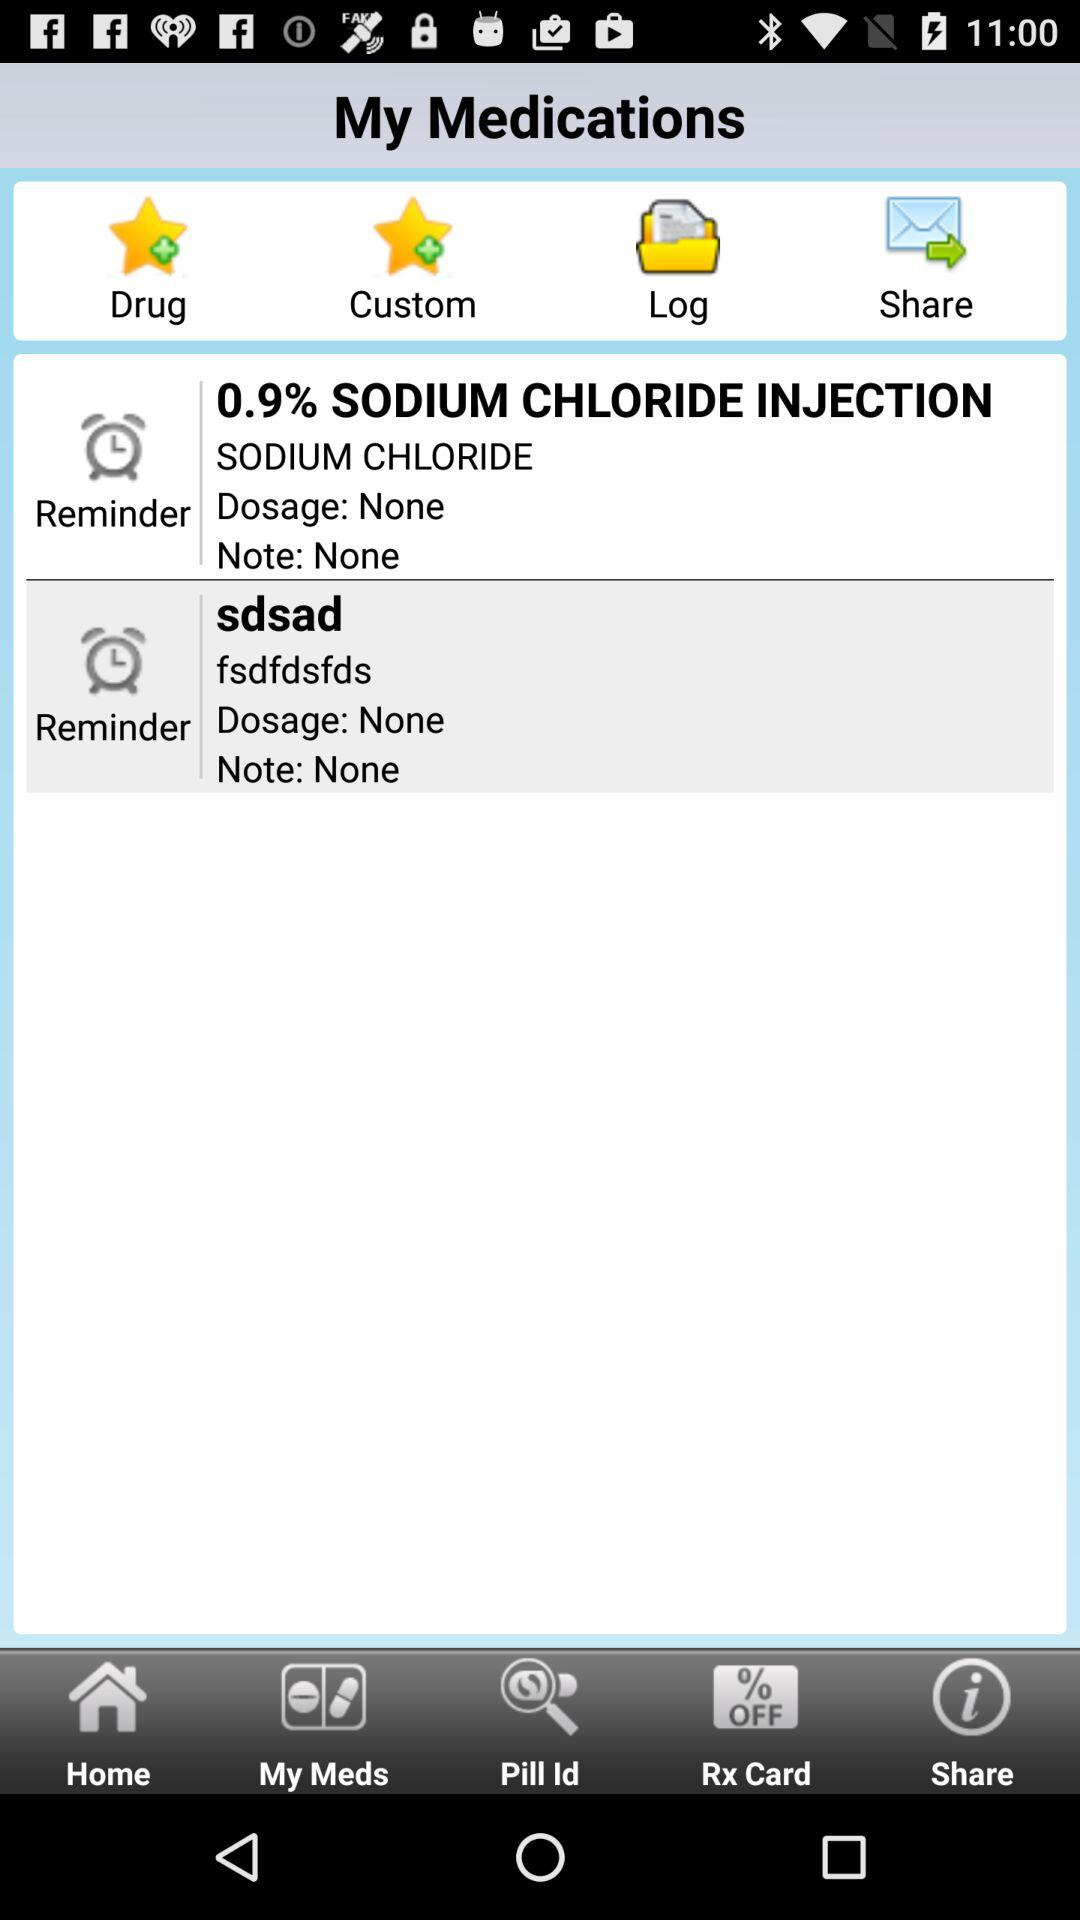How many medications do I have?
Answer the question using a single word or phrase. 2 